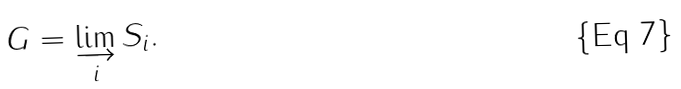<formula> <loc_0><loc_0><loc_500><loc_500>G = \varinjlim _ { i } S _ { i } .</formula> 